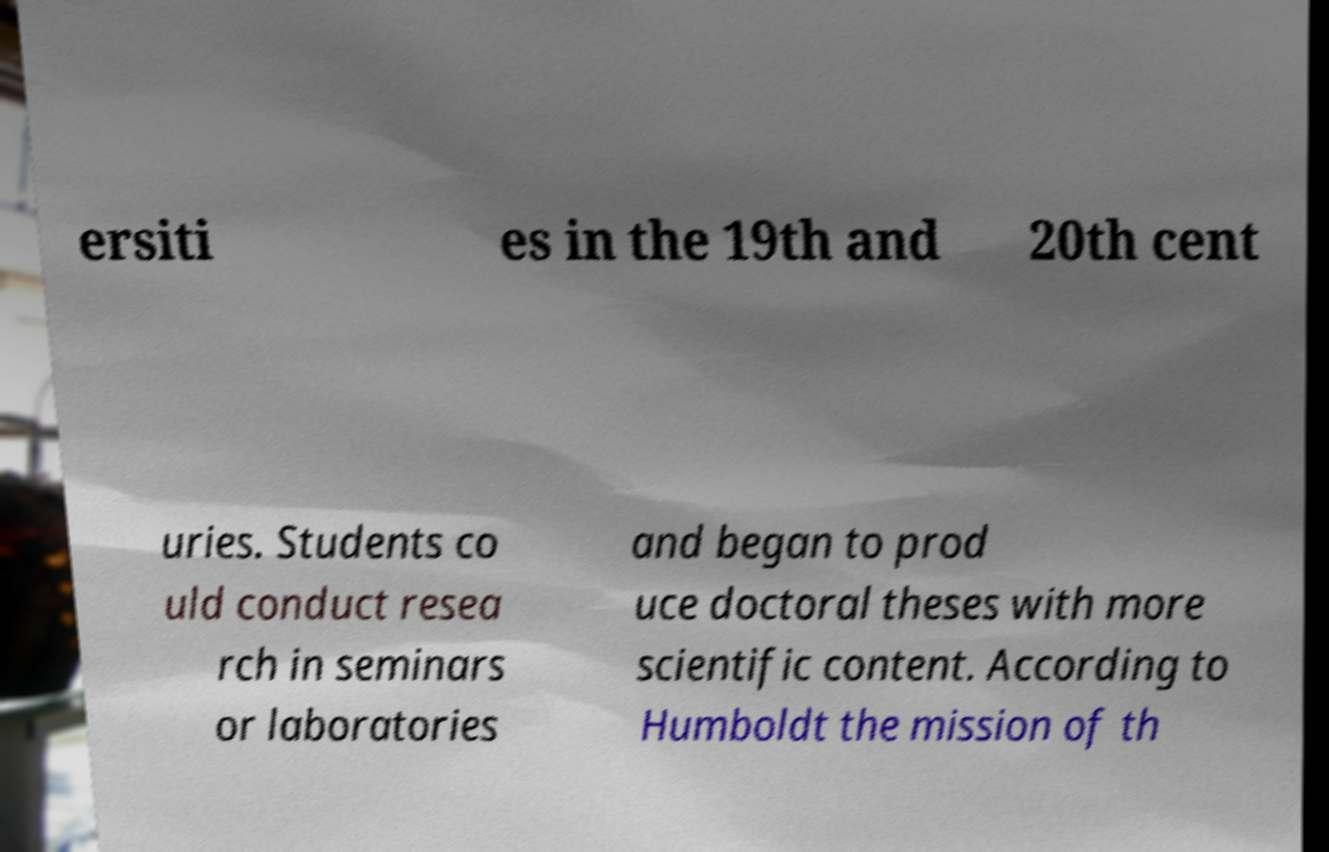Could you assist in decoding the text presented in this image and type it out clearly? ersiti es in the 19th and 20th cent uries. Students co uld conduct resea rch in seminars or laboratories and began to prod uce doctoral theses with more scientific content. According to Humboldt the mission of th 